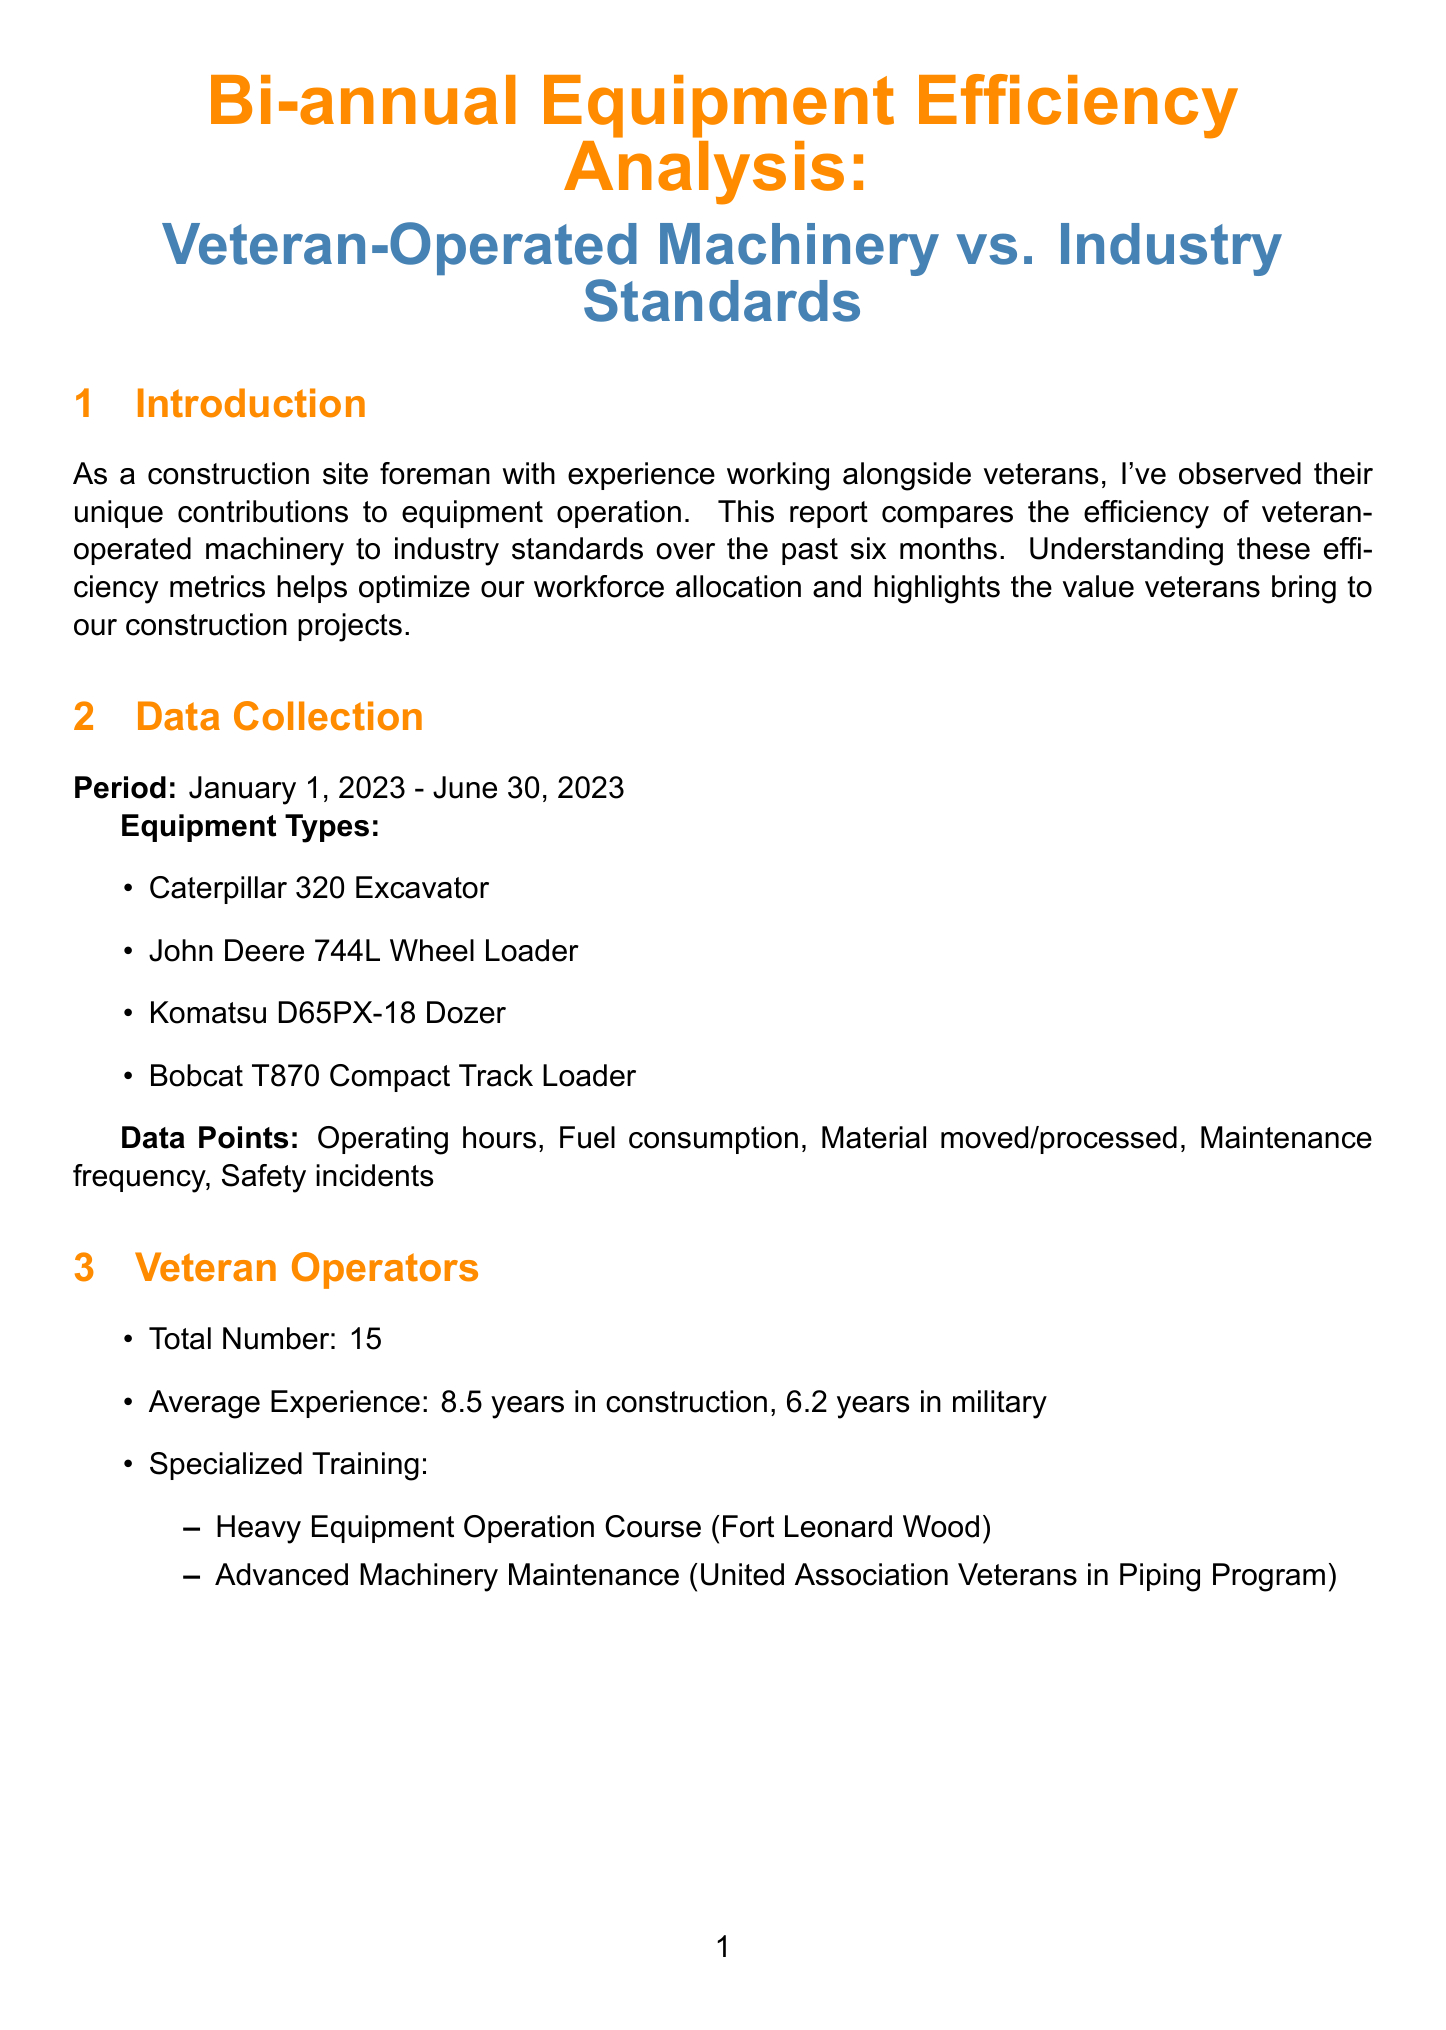what is the report title? The report title is clearly stated at the beginning of the document as the main heading.
Answer: Bi-annual Equipment Efficiency Analysis: Veteran-Operated Machinery vs. Industry Standards what is the observation period for the data? The observation period is specified in the Data Collection section of the document.
Answer: January 1, 2023 - June 30, 2023 how many veteran operators are included in the analysis? The total number of veteran operators is mentioned in the Veteran Operators section.
Answer: 15 what is the average experience of veteran operators in military years? The average experience in military years is provided in the Veteran Operators section.
Answer: 6.2 years how much fuel savings did veteran-operated machinery achieve over six months? The total fuel savings is detailed in the Economic Impact section of the document.
Answer: $28,500 what percentage more material did veteran operators move per hour compared to the industry standard? This information is found in the Efficiency Metrics section regarding productivity rates.
Answer: 9% who achieved 18% fuel savings on the Caterpillar 320 Excavator? The notable example for fuel efficiency is highlighted in the Efficiency Metrics section.
Answer: John Smith what initiative is recommended to enhance veteran operators' skills? The recommendations provided in the Conclusions section suggest ways to improve veteran skills.
Answer: Invest in additional specialized training how much was reduced in maintenance costs due to veterans? The amount saved in maintenance costs is listed in the Economic Impact section.
Answer: $42,000 what type of initiatives are suggested for future considerations? Future considerations include various categories proposed in the document.
Answer: Technology Adoption, Sustainability Initiatives, Skills Transfer 